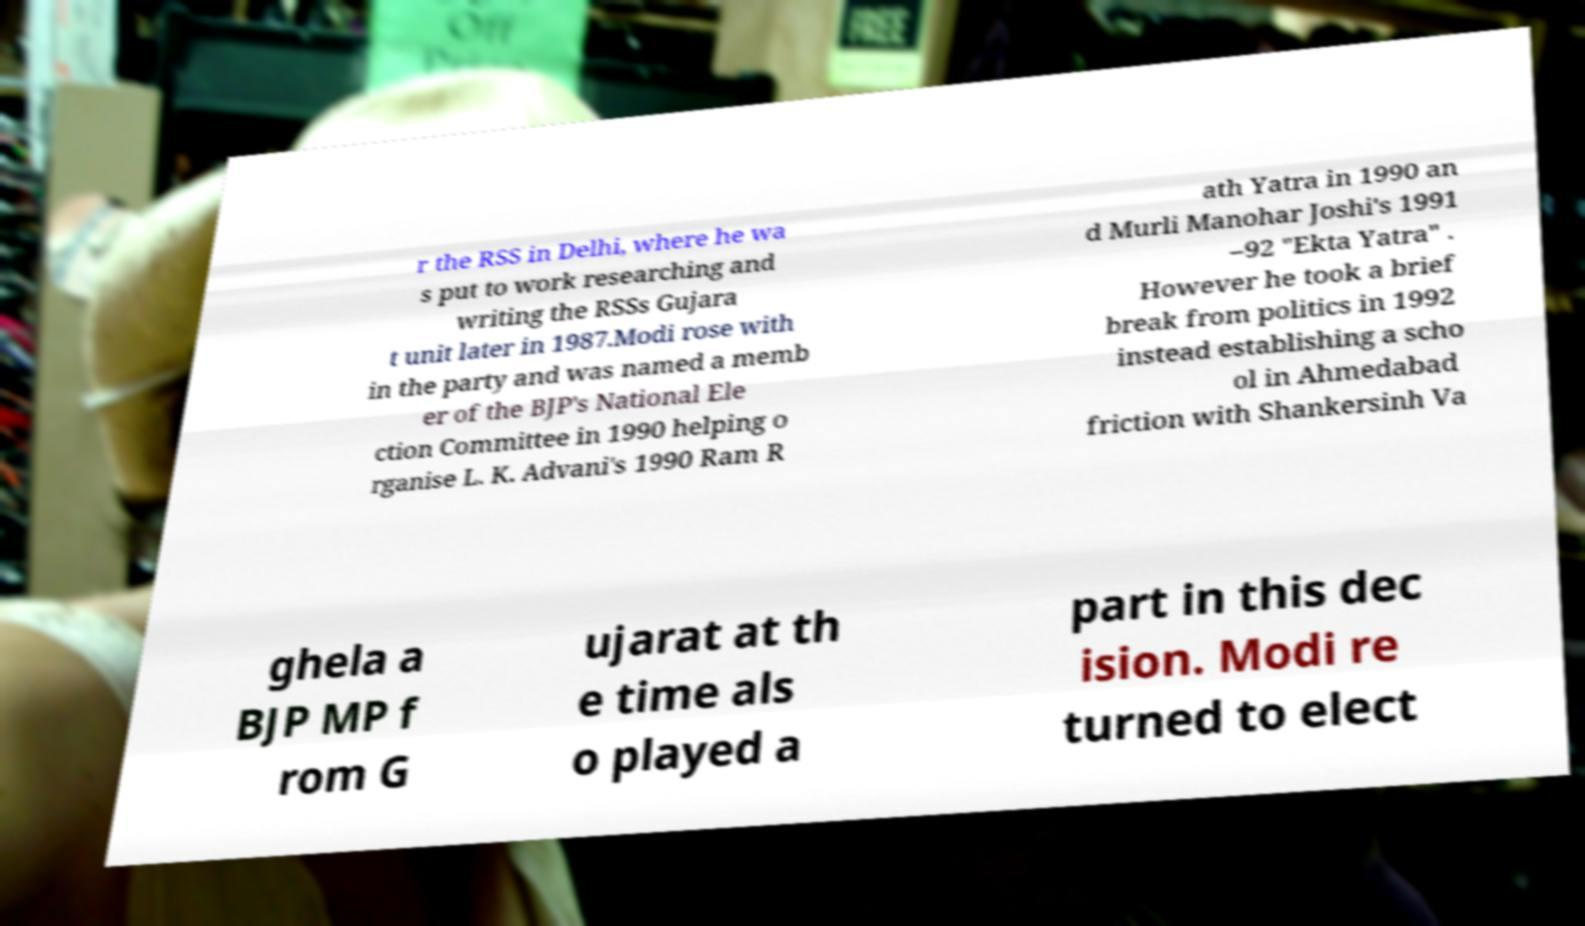Can you accurately transcribe the text from the provided image for me? r the RSS in Delhi, where he wa s put to work researching and writing the RSSs Gujara t unit later in 1987.Modi rose with in the party and was named a memb er of the BJP's National Ele ction Committee in 1990 helping o rganise L. K. Advani's 1990 Ram R ath Yatra in 1990 an d Murli Manohar Joshi's 1991 –92 "Ekta Yatra" . However he took a brief break from politics in 1992 instead establishing a scho ol in Ahmedabad friction with Shankersinh Va ghela a BJP MP f rom G ujarat at th e time als o played a part in this dec ision. Modi re turned to elect 